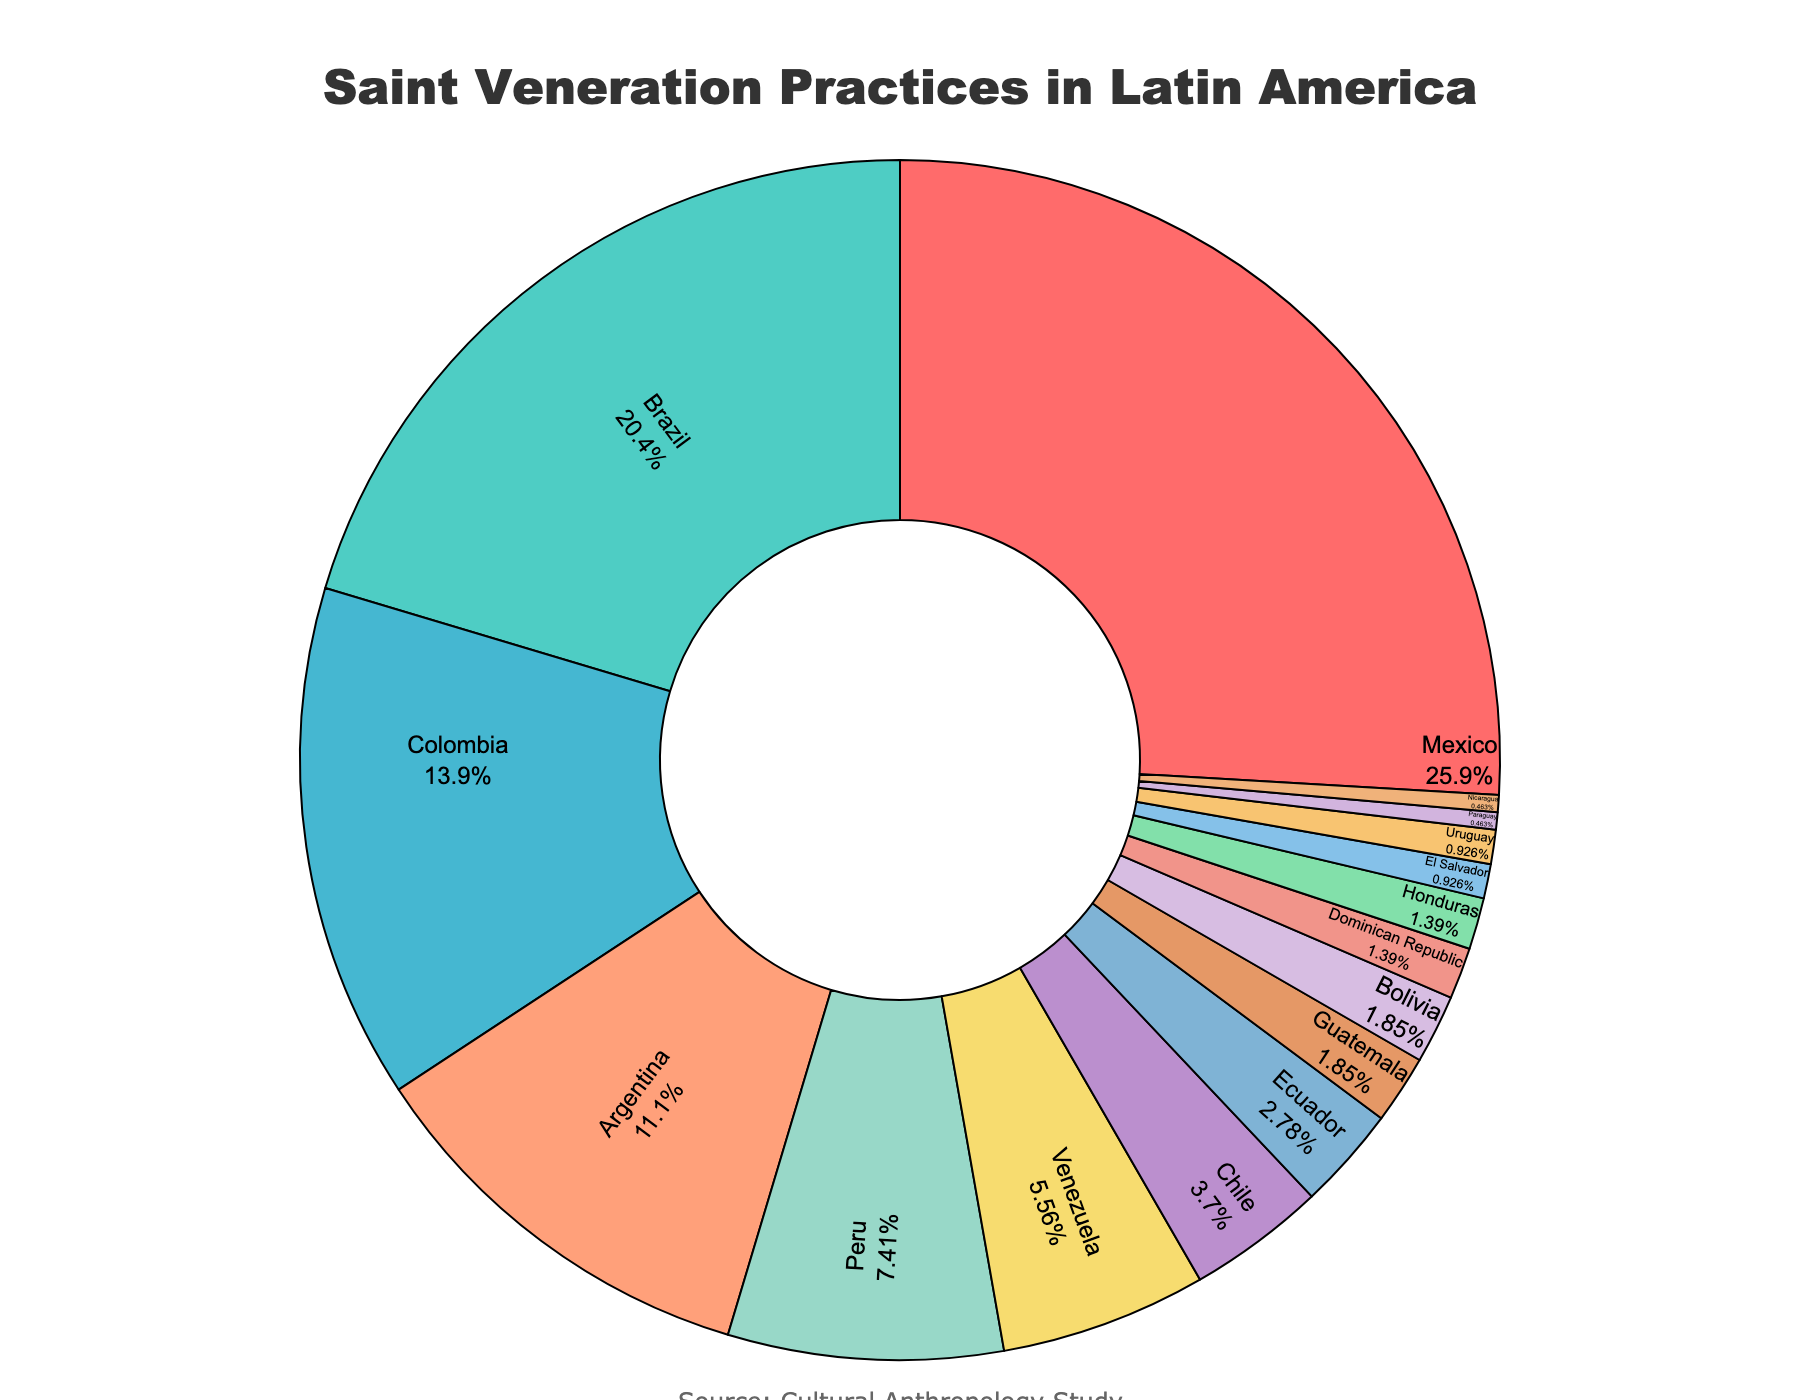Which country has the highest percentage of saint veneration practices? By looking at the pie chart, identify the country with the largest segment. This indicates the highest percentage.
Answer: Mexico Which country has a higher percentage of saint veneration practices, Brazil or Colombia? Compare the size of the segments for Brazil and Colombia. Brazil has a larger segment than Colombia.
Answer: Brazil What's the combined percentage for Argentina, Peru, and Venezuela? Sum the percentages of Argentina (12%), Peru (8%), and Venezuela (6%) which is 12 + 8 + 6 = 26%
Answer: 26% Which segment is larger, the sum of saint veneration practices in Chile and Ecuador or Guatemala and Bolivia? Add the percentages for Chile (4%) and Ecuador (3%), resulting in 7%. Then add the percentages for Guatemala (2%) and Bolivia (2%), resulting in 4%. Compare the two sums: 7% vs. 4%.
Answer: Chile and Ecuador What is the difference in percentage between Mexico and Nicaragua? Calculate the difference between Mexico (28%) and Nicaragua (0.5%), which is 28 - 0.5 = 27.5%
Answer: 27.5% Which country has a smaller percentage of saint veneration practices, Uruguay or El Salvador? Compare the pie chart segments for Uruguay (1%) and El Salvador (1%). Both have the same percentage of saint veneration practices.
Answer: Equal What is the total percentage of saint veneration practices of the countries that have more than 10%? Sum the percentages of countries with more than 10%: Mexico (28%), Brazil (22%), Colombia (15%), and Argentina (12%). This results in 28 + 22 + 15 + 12 = 77%.
Answer: 77% How much larger is the segment for Peru compared to that for Chile? Find the difference between the percentages for Peru (8%) and Chile (4%), which is 8 - 4 = 4%.
Answer: 4% What is the average percentage of saint veneration practices among the countries that have less than 2% each? Identify the countries with less than 2%: Dominican Republic (1.5%), Honduras (1.5%), El Salvador (1%), Uruguay (1%), Paraguay (0.5%), Nicaragua (0.5%). Calculate the average: (1.5 + 1.5 + 1 + 1 + 0.5 + 0.5) / 6 = 6 / 6 = 1%.
Answer: 1% 